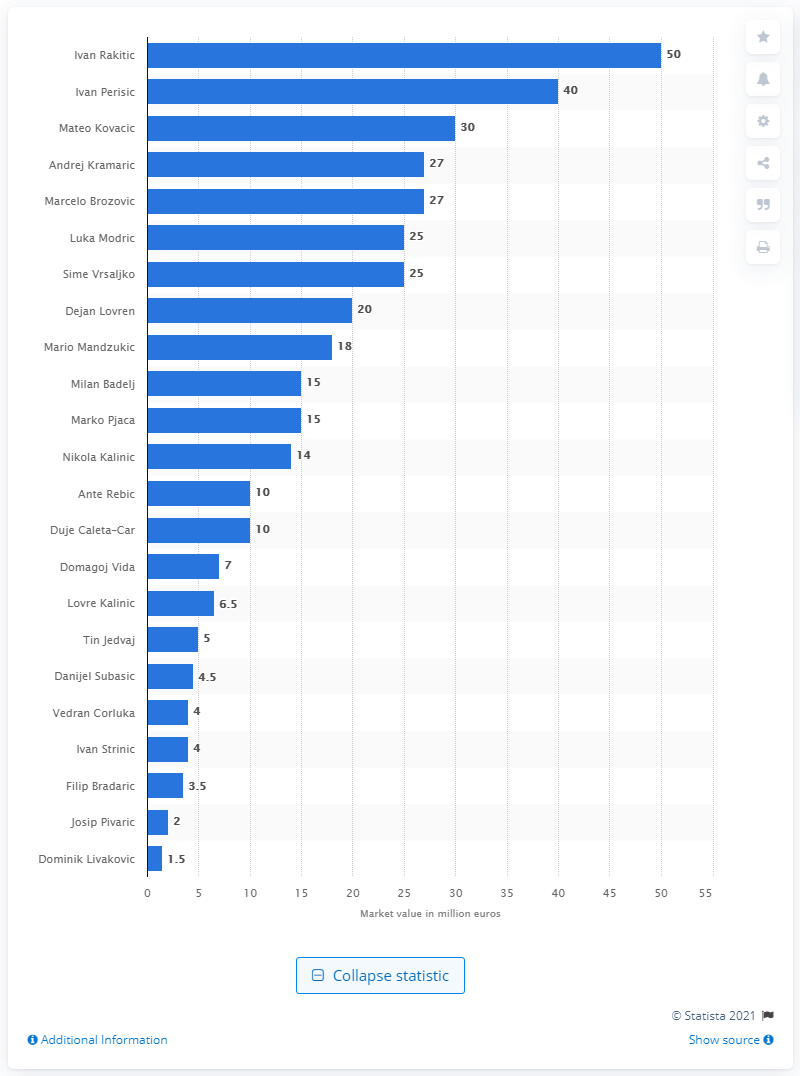Highlight a few significant elements in this photo. Ivan Rakitic's market value was estimated to be 50 million dollars. Ivan Rakitic was determined to be the most valuable player at the 2018 FIFA World Cup. 